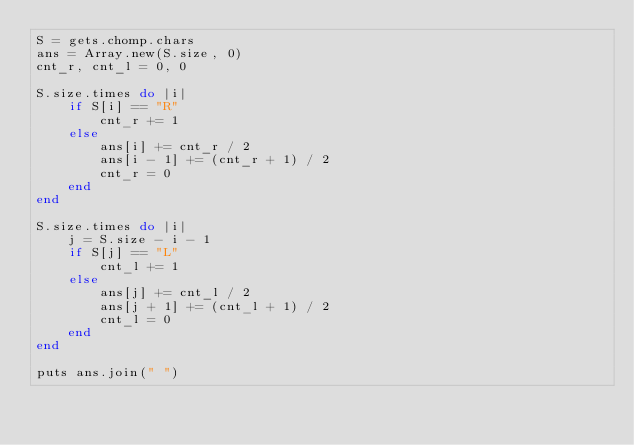<code> <loc_0><loc_0><loc_500><loc_500><_Ruby_>S = gets.chomp.chars
ans = Array.new(S.size, 0)
cnt_r, cnt_l = 0, 0

S.size.times do |i|
    if S[i] == "R"
        cnt_r += 1
    else
        ans[i] += cnt_r / 2
        ans[i - 1] += (cnt_r + 1) / 2
        cnt_r = 0
    end
end

S.size.times do |i|
    j = S.size - i - 1
    if S[j] == "L"
        cnt_l += 1
    else
        ans[j] += cnt_l / 2
        ans[j + 1] += (cnt_l + 1) / 2
        cnt_l = 0
    end
end

puts ans.join(" ")


</code> 